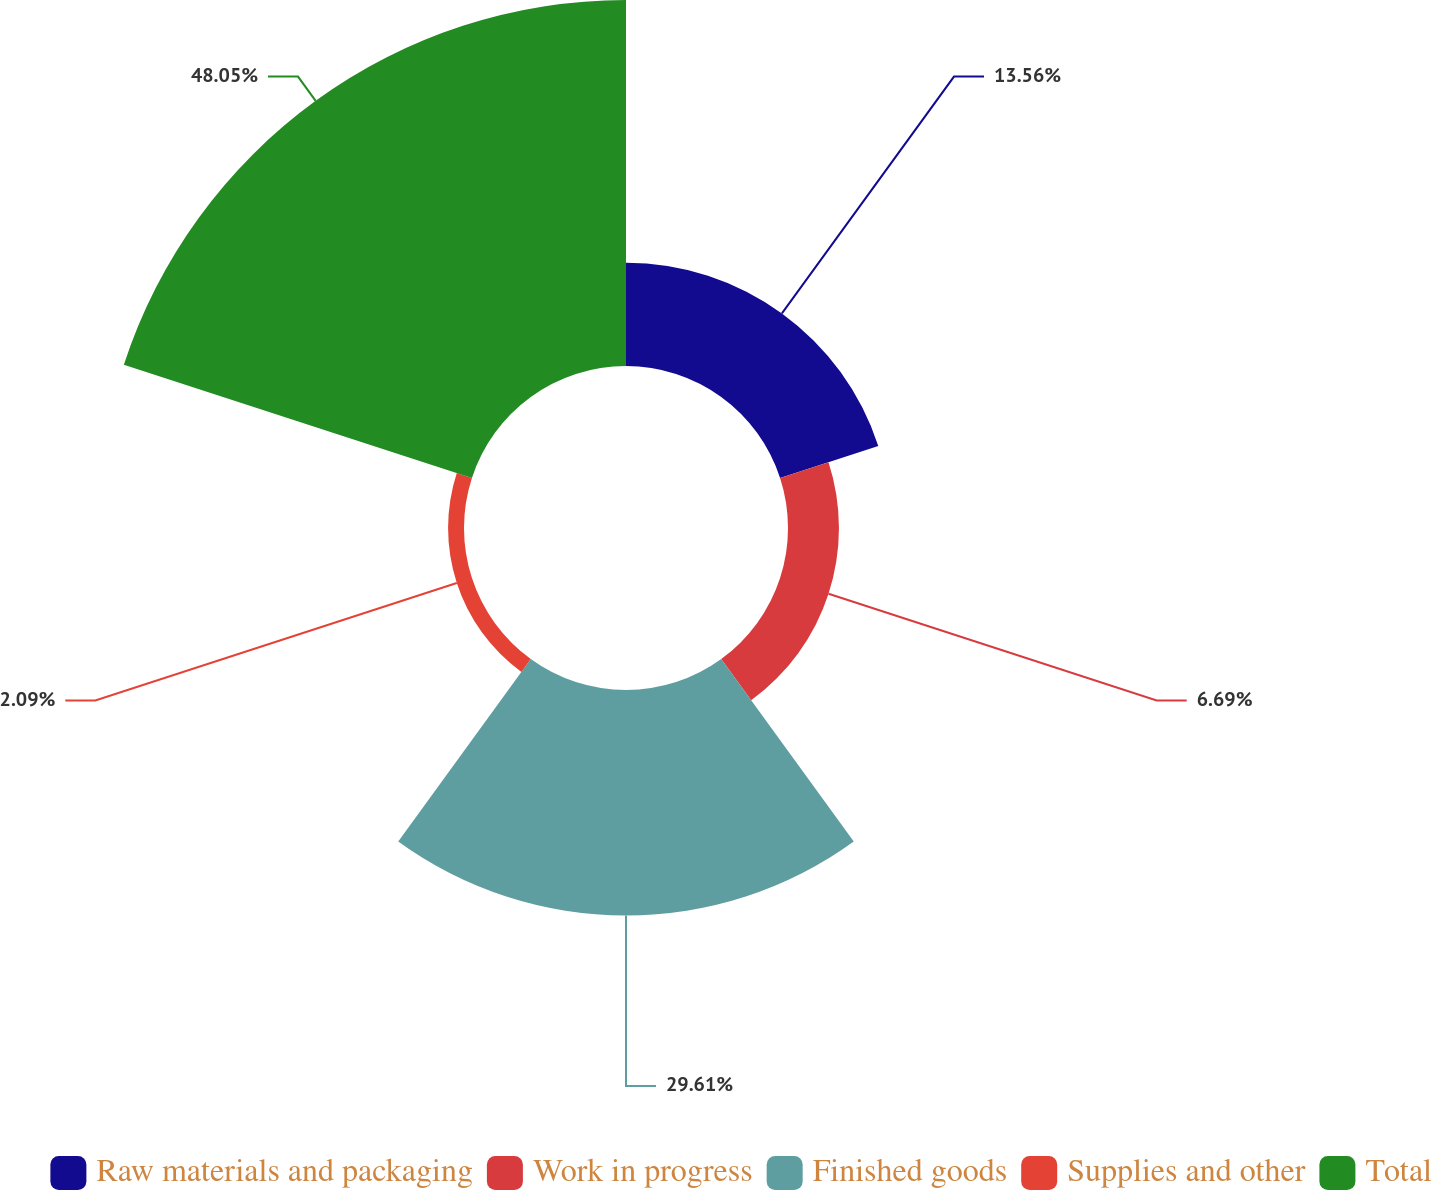<chart> <loc_0><loc_0><loc_500><loc_500><pie_chart><fcel>Raw materials and packaging<fcel>Work in progress<fcel>Finished goods<fcel>Supplies and other<fcel>Total<nl><fcel>13.56%<fcel>6.69%<fcel>29.61%<fcel>2.09%<fcel>48.06%<nl></chart> 